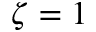<formula> <loc_0><loc_0><loc_500><loc_500>\zeta = 1</formula> 